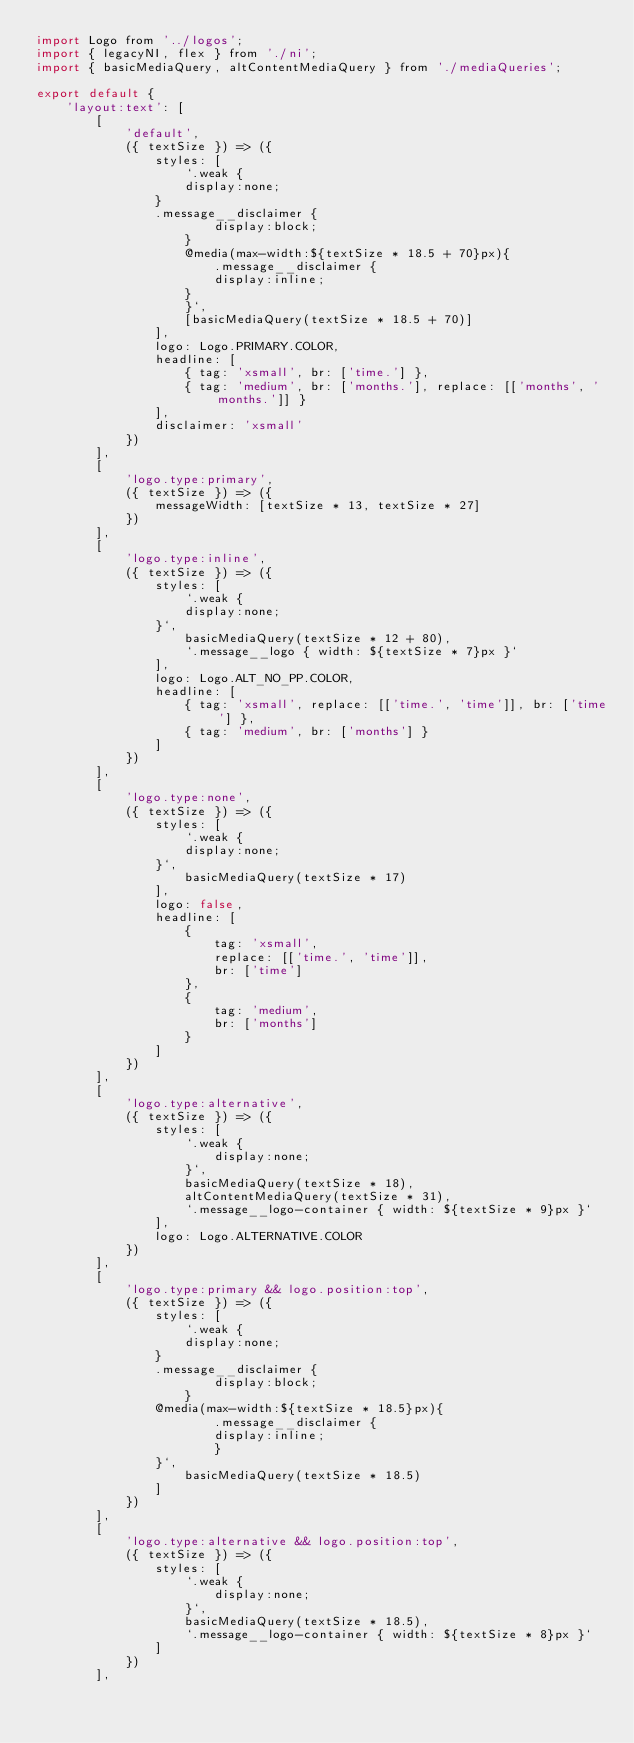<code> <loc_0><loc_0><loc_500><loc_500><_JavaScript_>import Logo from '../logos';
import { legacyNI, flex } from './ni';
import { basicMediaQuery, altContentMediaQuery } from './mediaQueries';

export default {
    'layout:text': [
        [
            'default',
            ({ textSize }) => ({
                styles: [
                    `.weak {
                    display:none;
                }
                .message__disclaimer {
                        display:block;
                    }
                    @media(max-width:${textSize * 18.5 + 70}px){
                        .message__disclaimer {
                        display:inline;
                    }
                    }`,
                    [basicMediaQuery(textSize * 18.5 + 70)]
                ],
                logo: Logo.PRIMARY.COLOR,
                headline: [
                    { tag: 'xsmall', br: ['time.'] },
                    { tag: 'medium', br: ['months.'], replace: [['months', 'months.']] }
                ],
                disclaimer: 'xsmall'
            })
        ],
        [
            'logo.type:primary',
            ({ textSize }) => ({
                messageWidth: [textSize * 13, textSize * 27]
            })
        ],
        [
            'logo.type:inline',
            ({ textSize }) => ({
                styles: [
                    `.weak {
                    display:none;
                }`,
                    basicMediaQuery(textSize * 12 + 80),
                    `.message__logo { width: ${textSize * 7}px }`
                ],
                logo: Logo.ALT_NO_PP.COLOR,
                headline: [
                    { tag: 'xsmall', replace: [['time.', 'time']], br: ['time'] },
                    { tag: 'medium', br: ['months'] }
                ]
            })
        ],
        [
            'logo.type:none',
            ({ textSize }) => ({
                styles: [
                    `.weak {
                    display:none;
                }`,
                    basicMediaQuery(textSize * 17)
                ],
                logo: false,
                headline: [
                    {
                        tag: 'xsmall',
                        replace: [['time.', 'time']],
                        br: ['time']
                    },
                    {
                        tag: 'medium',
                        br: ['months']
                    }
                ]
            })
        ],
        [
            'logo.type:alternative',
            ({ textSize }) => ({
                styles: [
                    `.weak {
                        display:none;
                    }`,
                    basicMediaQuery(textSize * 18),
                    altContentMediaQuery(textSize * 31),
                    `.message__logo-container { width: ${textSize * 9}px }`
                ],
                logo: Logo.ALTERNATIVE.COLOR
            })
        ],
        [
            'logo.type:primary && logo.position:top',
            ({ textSize }) => ({
                styles: [
                    `.weak {
                    display:none;
                }
                .message__disclaimer {
                        display:block;
                    }
                @media(max-width:${textSize * 18.5}px){
                        .message__disclaimer {
                        display:inline;
                        }
                }`,
                    basicMediaQuery(textSize * 18.5)
                ]
            })
        ],
        [
            'logo.type:alternative && logo.position:top',
            ({ textSize }) => ({
                styles: [
                    `.weak {
                        display:none;
                    }`,
                    basicMediaQuery(textSize * 18.5),
                    `.message__logo-container { width: ${textSize * 8}px }`
                ]
            })
        ],</code> 